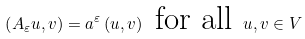Convert formula to latex. <formula><loc_0><loc_0><loc_500><loc_500>\left ( A _ { \varepsilon } u , v \right ) = a ^ { \varepsilon } \left ( u , v \right ) \text { for all } u , v \in V</formula> 